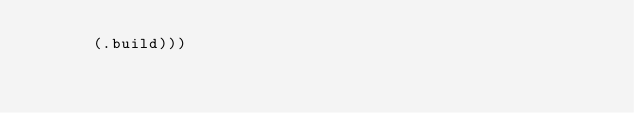Convert code to text. <code><loc_0><loc_0><loc_500><loc_500><_Clojure_>      (.build)))

</code> 